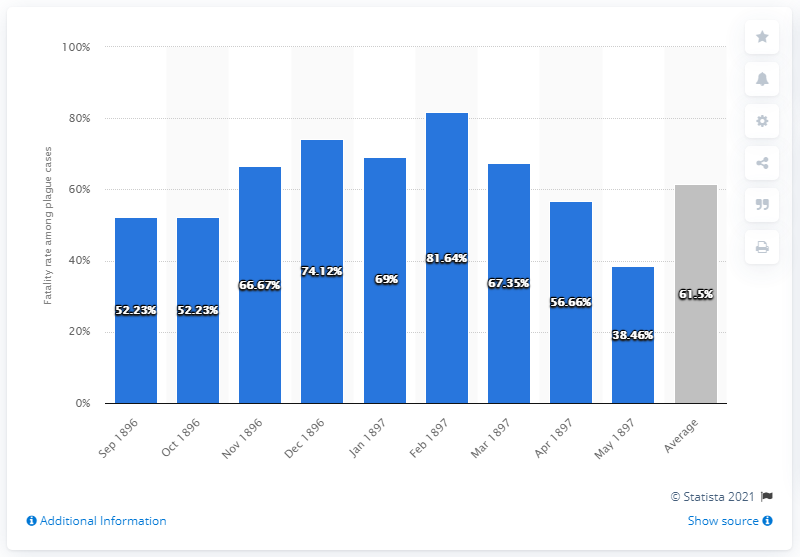Highlight a few significant elements in this photo. The fatality rate in plague cases between September 1896 and May 1897 was 61.5%. The fatality rate among plague cases varied by month, with the highest rate occurring in July and the lowest rate occurring in December. 